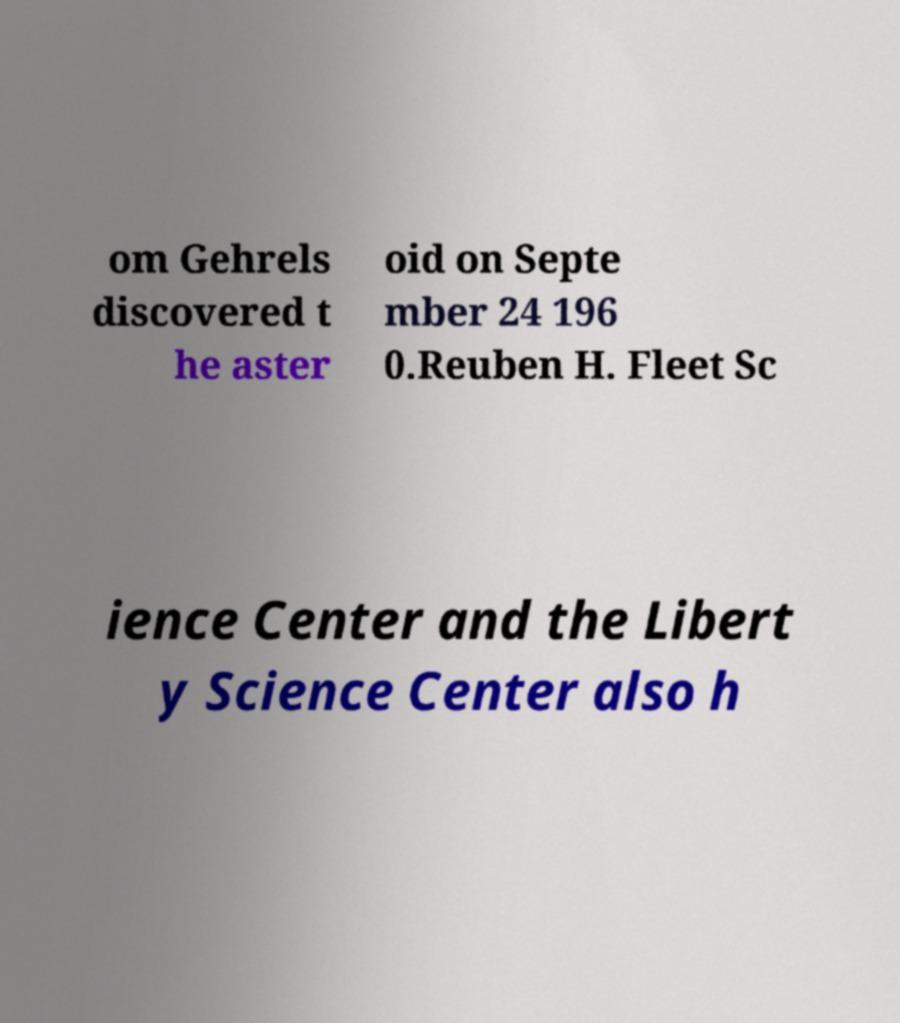I need the written content from this picture converted into text. Can you do that? om Gehrels discovered t he aster oid on Septe mber 24 196 0.Reuben H. Fleet Sc ience Center and the Libert y Science Center also h 